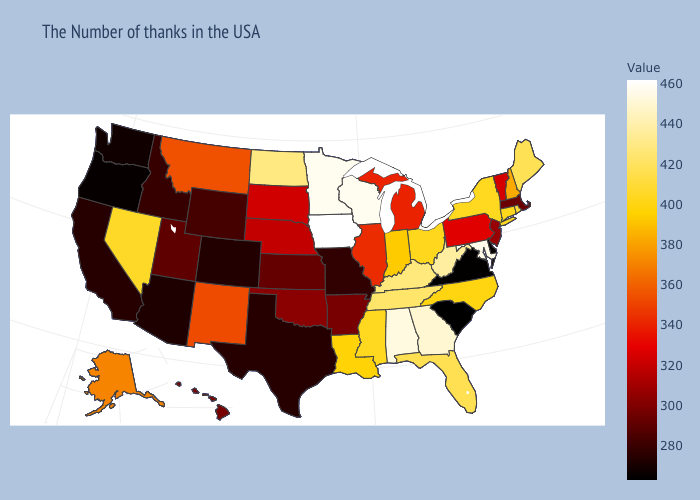Which states hav the highest value in the South?
Write a very short answer. Maryland. Does South Dakota have a lower value than Maryland?
Write a very short answer. Yes. Among the states that border Kentucky , which have the highest value?
Give a very brief answer. West Virginia. Does Pennsylvania have the lowest value in the Northeast?
Write a very short answer. No. 